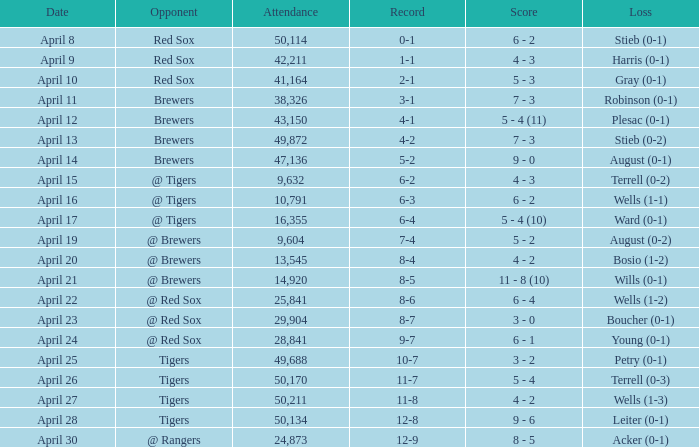Which competitor boasts of an attendance higher than 29,904 and an 11-8 track record? Tigers. 